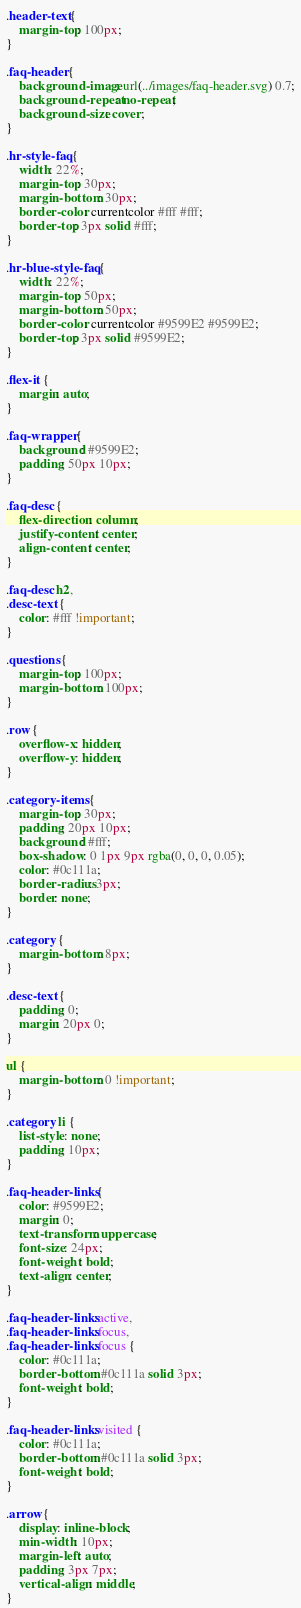Convert code to text. <code><loc_0><loc_0><loc_500><loc_500><_CSS_>.header-text {
    margin-top: 100px;
}

.faq-header {
    background-image: url(../images/faq-header.svg) 0.7;
    background-repeat: no-repeat;
    background-size: cover;
}

.hr-style-faq {
    width: 22%;
    margin-top: 30px;
    margin-bottom: 30px;
    border-color: currentcolor #fff #fff;
    border-top: 3px solid #fff;
}

.hr-blue-style-faq {
    width: 22%;
    margin-top: 50px;
    margin-bottom: 50px;
    border-color: currentcolor #9599E2 #9599E2;
    border-top: 3px solid #9599E2;
}

.flex-it {
    margin: auto;
}

.faq-wrapper {
    background: #9599E2;
    padding: 50px 10px;
}

.faq-desc {
    flex-direction: column;
    justify-content: center;
    align-content: center;
}

.faq-desc h2,
.desc-text {
    color: #fff !important;
}

.questions {
    margin-top: 100px;
    margin-bottom: 100px;
}

.row {
    overflow-x: hidden;
    overflow-y: hidden;
}

.category-items {
    margin-top: 30px;
    padding: 20px 10px;
    background: #fff;
    box-shadow: 0 1px 9px rgba(0, 0, 0, 0.05);
    color: #0c111a;
    border-radius: 3px;
    border: none;
}

.category {
    margin-bottom: 8px;
}

.desc-text {
    padding: 0;
    margin: 20px 0;
}

ul {
    margin-bottom: 0 !important;
}

.category li {
    list-style: none;
    padding: 10px;
}

.faq-header-links {
    color: #9599E2;
    margin: 0;
    text-transform: uppercase;
    font-size: 24px;
    font-weight: bold;
    text-align: center;
}

.faq-header-links:active,
.faq-header-links:focus,
.faq-header-links:focus {
    color: #0c111a;
    border-bottom: #0c111a solid 3px;
    font-weight: bold;
}

.faq-header-links:visited {
    color: #0c111a;
    border-bottom: #0c111a solid 3px;
    font-weight: bold;
}

.arrow {
    display: inline-block;
    min-width: 10px;
    margin-left: auto;
    padding: 3px 7px;
    vertical-align: middle;
}
</code> 